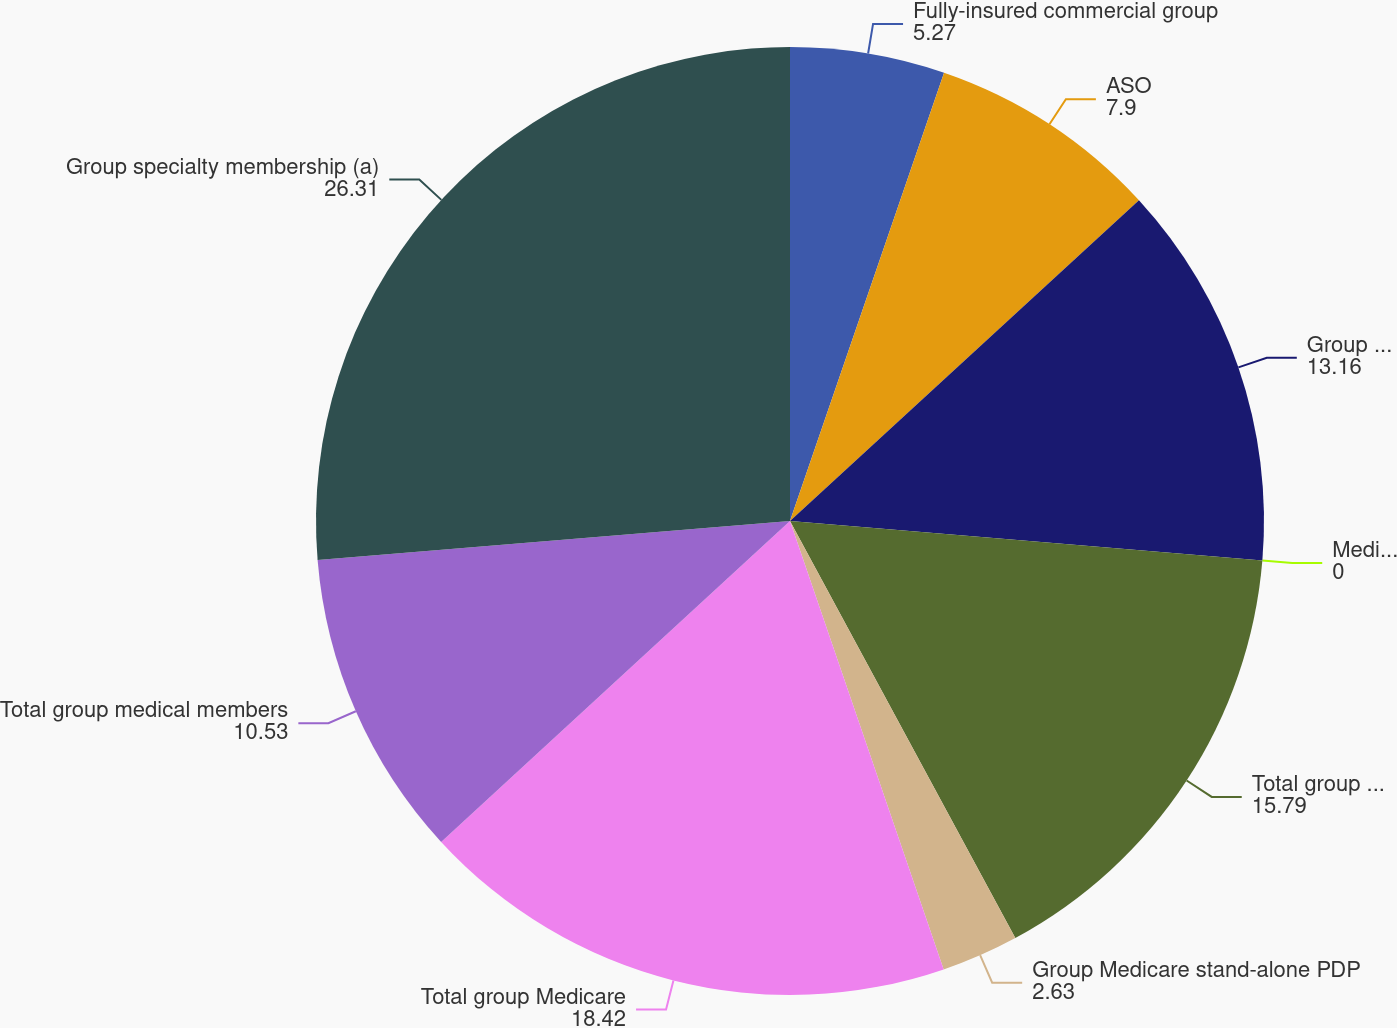Convert chart. <chart><loc_0><loc_0><loc_500><loc_500><pie_chart><fcel>Fully-insured commercial group<fcel>ASO<fcel>Group Medicare Advantage<fcel>Medicare Advantage ASO<fcel>Total group Medicare Advantage<fcel>Group Medicare stand-alone PDP<fcel>Total group Medicare<fcel>Total group medical members<fcel>Group specialty membership (a)<nl><fcel>5.27%<fcel>7.9%<fcel>13.16%<fcel>0.0%<fcel>15.79%<fcel>2.63%<fcel>18.42%<fcel>10.53%<fcel>26.31%<nl></chart> 